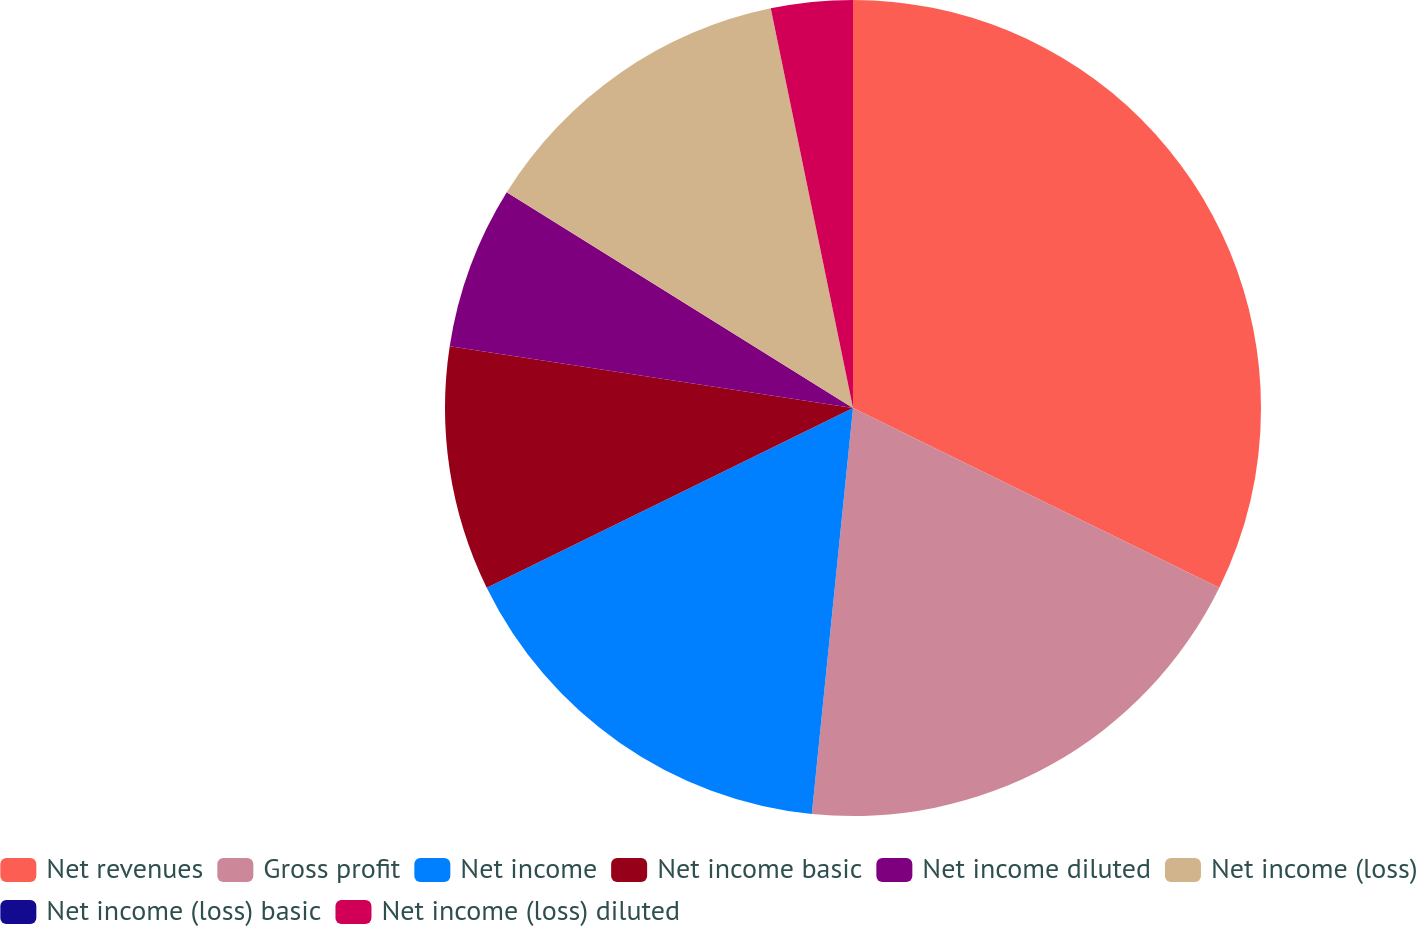Convert chart. <chart><loc_0><loc_0><loc_500><loc_500><pie_chart><fcel>Net revenues<fcel>Gross profit<fcel>Net income<fcel>Net income basic<fcel>Net income diluted<fcel>Net income (loss)<fcel>Net income (loss) basic<fcel>Net income (loss) diluted<nl><fcel>32.26%<fcel>19.35%<fcel>16.13%<fcel>9.68%<fcel>6.45%<fcel>12.9%<fcel>0.0%<fcel>3.23%<nl></chart> 